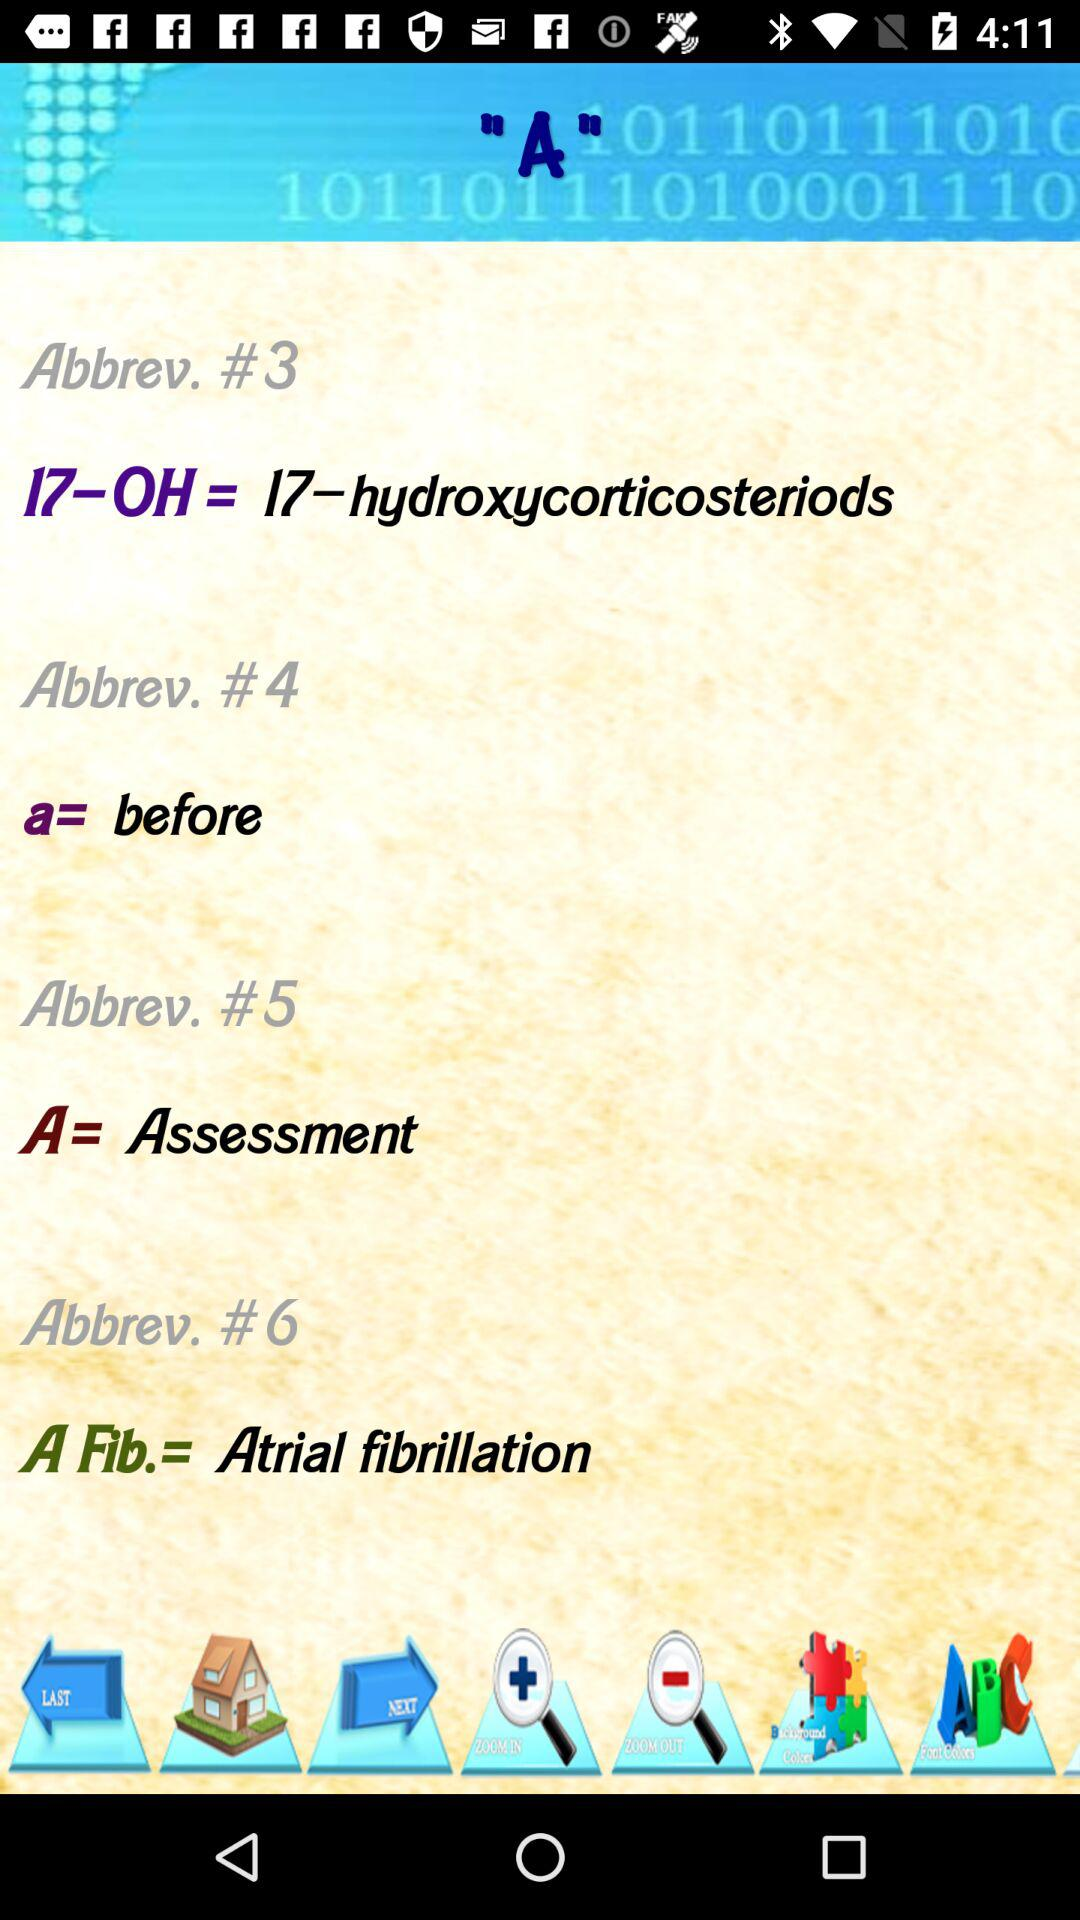What's in Abbreviation #5? In Abbreviation#5, A = Assessment is there. 